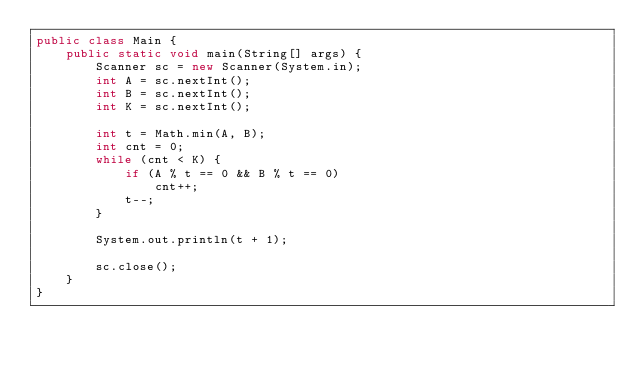Convert code to text. <code><loc_0><loc_0><loc_500><loc_500><_Java_>public class Main {
	public static void main(String[] args) {
		Scanner sc = new Scanner(System.in);
		int A = sc.nextInt();
		int B = sc.nextInt();
		int K = sc.nextInt();

		int t = Math.min(A, B);
		int cnt = 0;
		while (cnt < K) {
			if (A % t == 0 && B % t == 0)
				cnt++;
			t--;
		}

		System.out.println(t + 1);

		sc.close();
	}
}</code> 